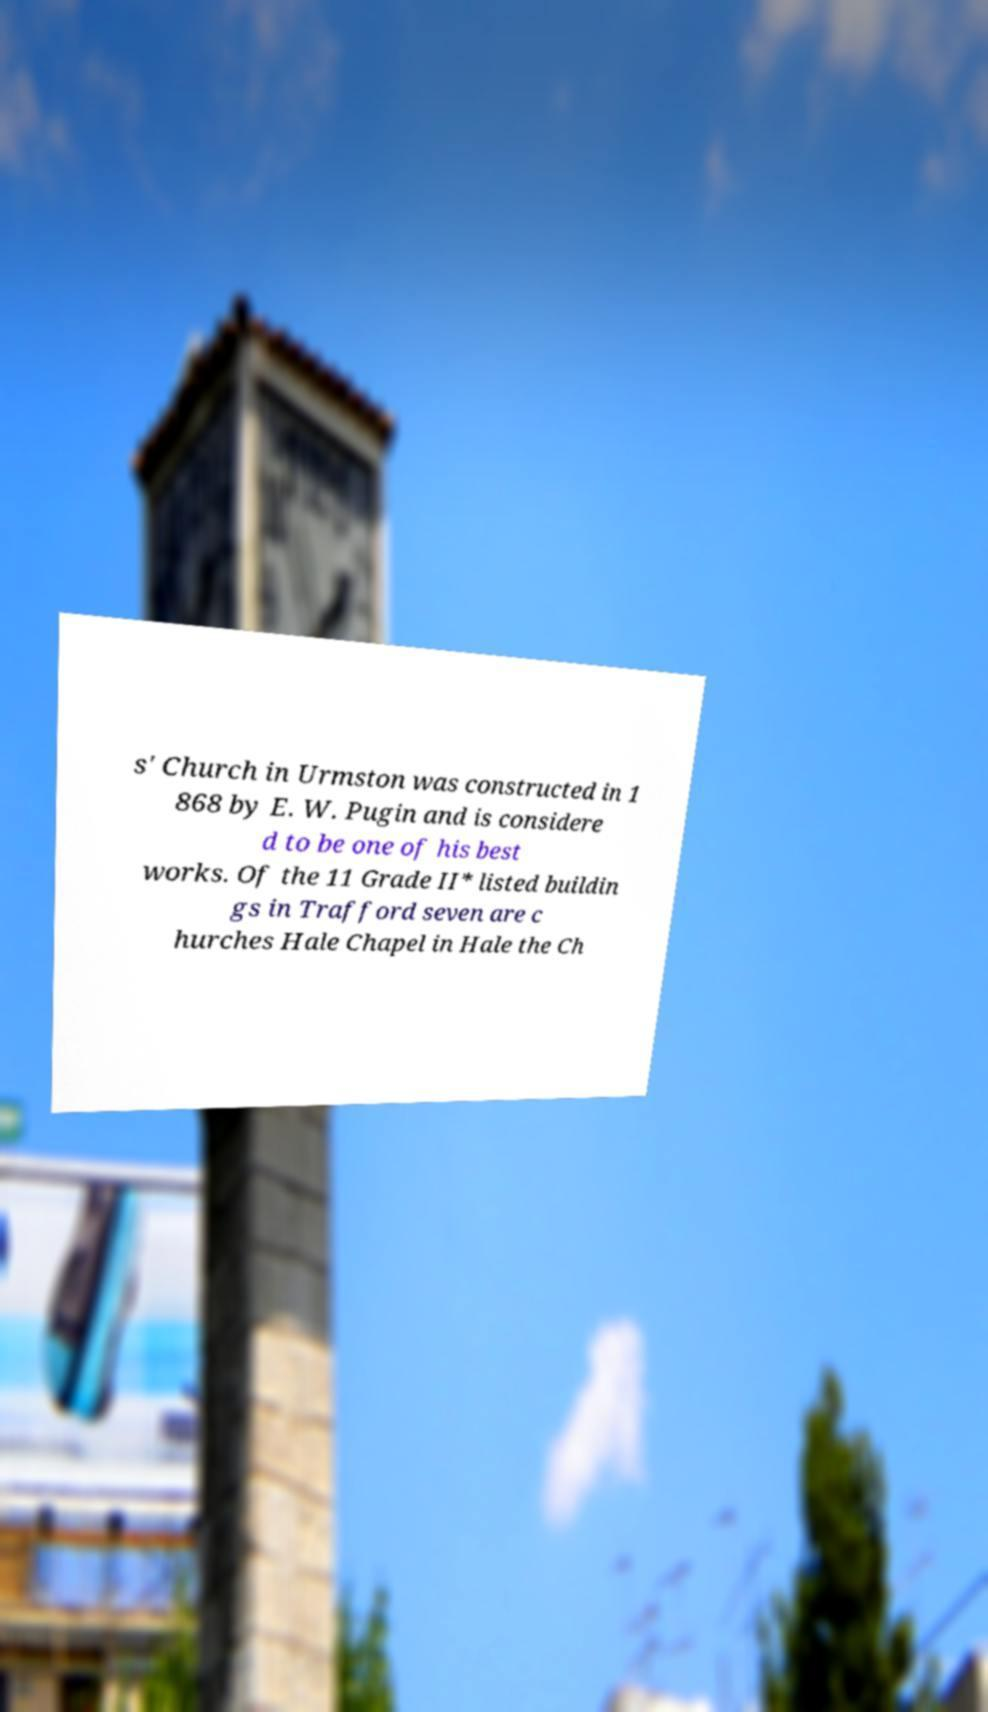There's text embedded in this image that I need extracted. Can you transcribe it verbatim? s' Church in Urmston was constructed in 1 868 by E. W. Pugin and is considere d to be one of his best works. Of the 11 Grade II* listed buildin gs in Trafford seven are c hurches Hale Chapel in Hale the Ch 